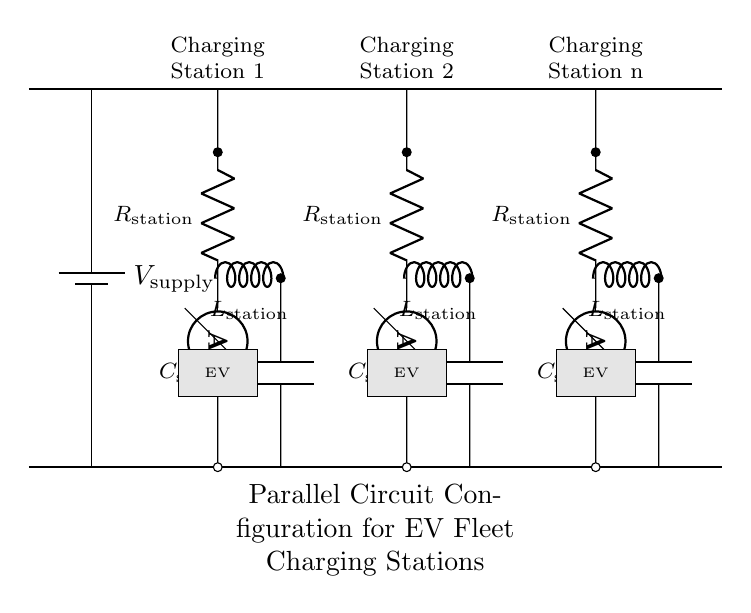What is the total number of charging stations in this circuit? There are three charging stations represented in the diagram, indicated by the three pairs of components labeled between the bus bars.
Answer: three What type of circuit is depicted in the diagram? The diagram displays a parallel circuit configuration, characterized by multiple paths for current to flow to the charging stations.
Answer: parallel What component is used for measuring current at each charging station? An ammeter is used at each charging station to measure the current flowing through that path.
Answer: ammeter Which components are present at each charging station? Each charging station includes a resistor, an inductor, and a capacitor, as shown in the structure of the circuit.
Answer: resistor, inductor, capacitor How are the charging stations connected to the voltage supply? The charging stations are directly connected to the bus bars, which are connected to the voltage supply, allowing parallel connections.
Answer: parallel connections What is the purpose of the bus bars in this configuration? The bus bars serve as a common conductor providing uniform voltage to multiple charging stations in parallel, ensuring stable connections.
Answer: common conductor If one charging station disconnects, how does it affect the others? The other charging stations remain unaffected due to the parallel nature of the circuit, allowing current to still flow through them.
Answer: unaffected 